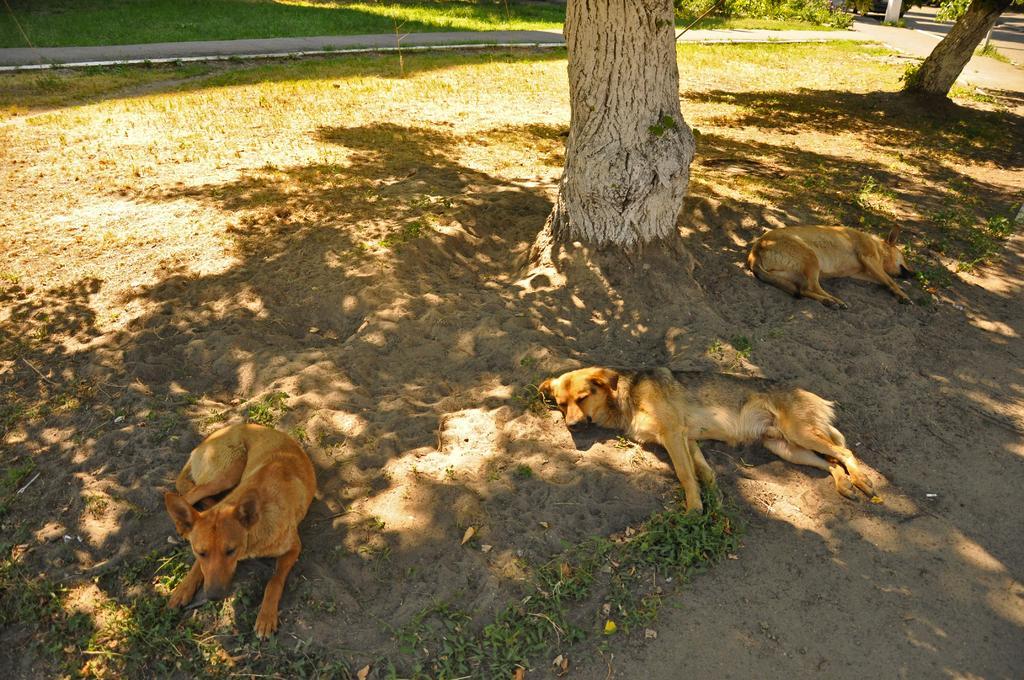Could you give a brief overview of what you see in this image? In the image to the front there are three dogs sleeping on the sand. on the sand there are leaves and also there is a tree. To the top of the image there is a grass and also there is a road. 